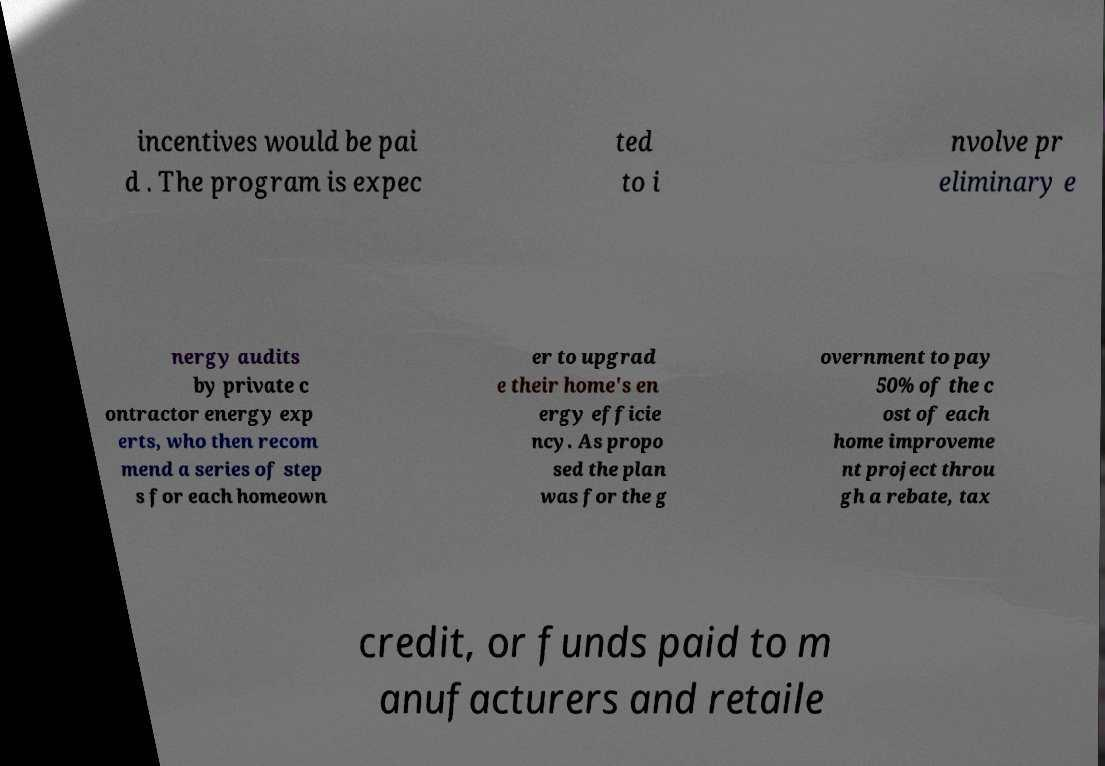Please read and relay the text visible in this image. What does it say? incentives would be pai d . The program is expec ted to i nvolve pr eliminary e nergy audits by private c ontractor energy exp erts, who then recom mend a series of step s for each homeown er to upgrad e their home's en ergy efficie ncy. As propo sed the plan was for the g overnment to pay 50% of the c ost of each home improveme nt project throu gh a rebate, tax credit, or funds paid to m anufacturers and retaile 